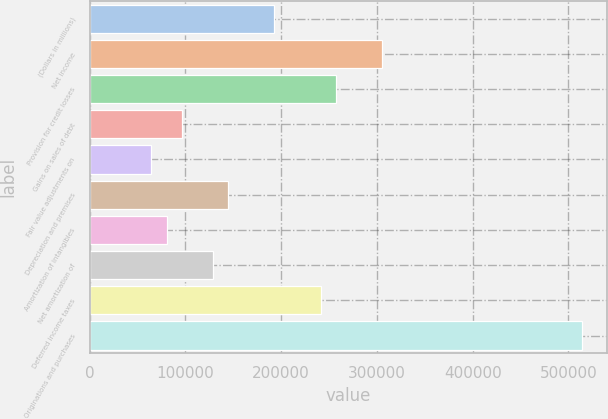Convert chart to OTSL. <chart><loc_0><loc_0><loc_500><loc_500><bar_chart><fcel>(Dollars in millions)<fcel>Net income<fcel>Provision for credit losses<fcel>Gains on sales of debt<fcel>Fair value adjustments on<fcel>Depreciation and premises<fcel>Amortization of intangibles<fcel>Net amortization of<fcel>Deferred income taxes<fcel>Originations and purchases<nl><fcel>192890<fcel>305403<fcel>257183<fcel>96451.2<fcel>64304.8<fcel>144671<fcel>80378<fcel>128598<fcel>241110<fcel>514354<nl></chart> 